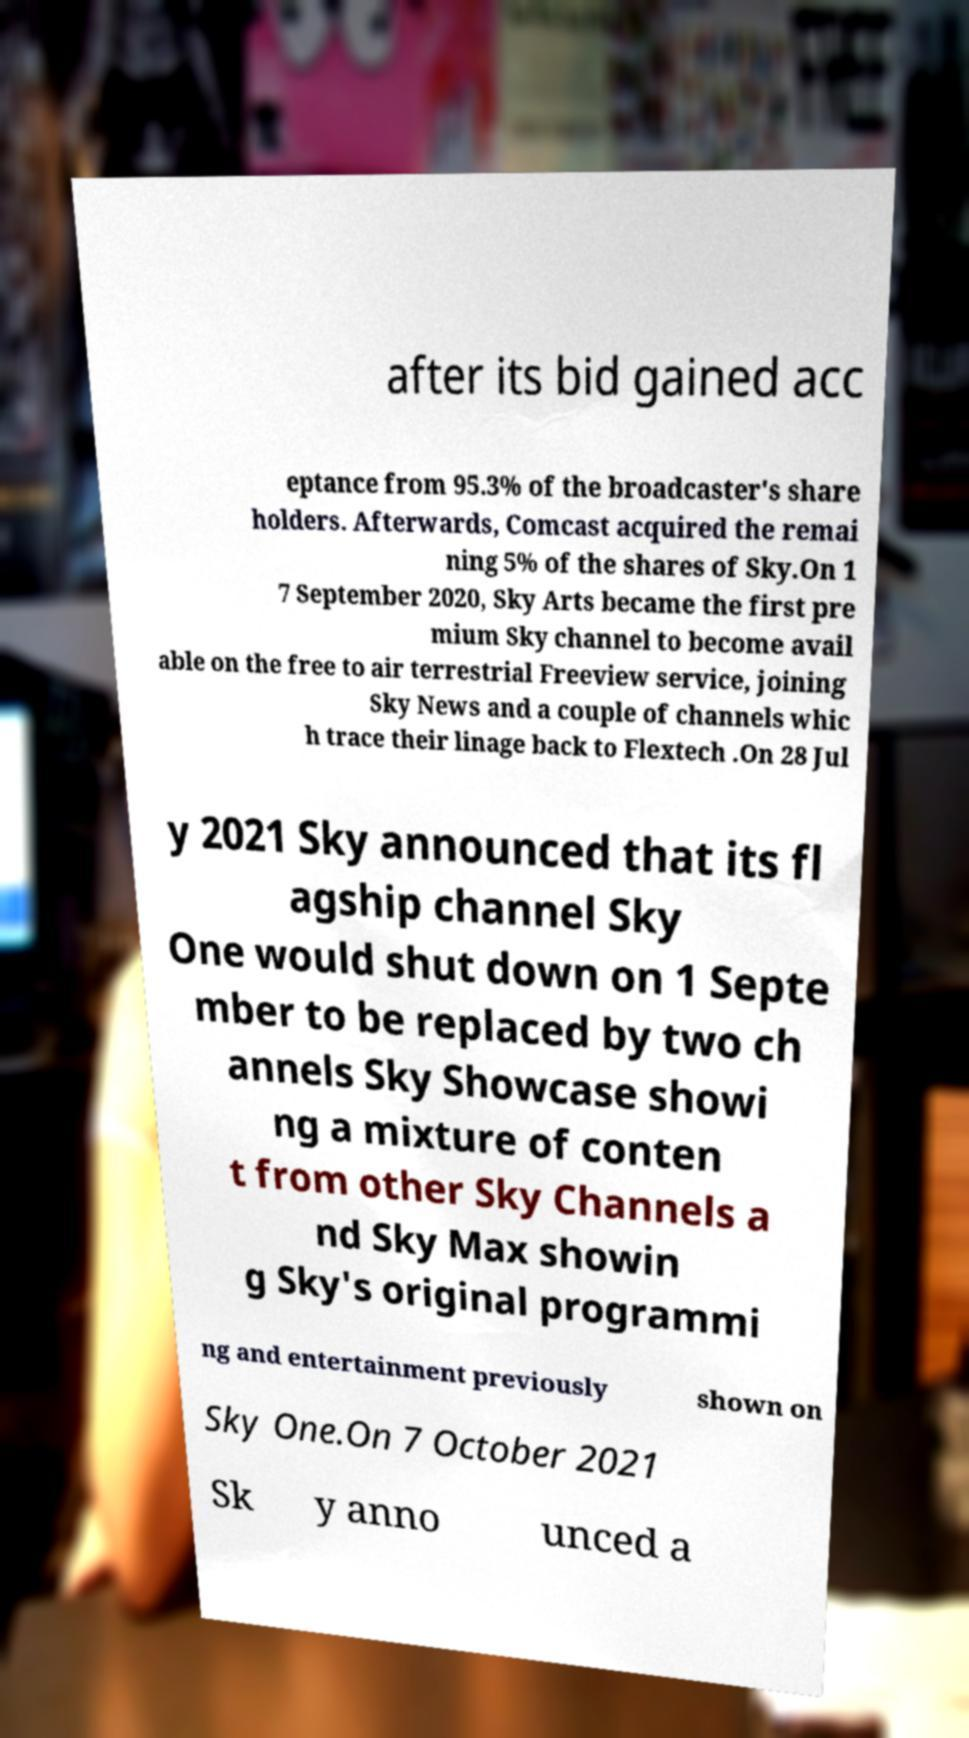Could you assist in decoding the text presented in this image and type it out clearly? after its bid gained acc eptance from 95.3% of the broadcaster's share holders. Afterwards, Comcast acquired the remai ning 5% of the shares of Sky.On 1 7 September 2020, Sky Arts became the first pre mium Sky channel to become avail able on the free to air terrestrial Freeview service, joining Sky News and a couple of channels whic h trace their linage back to Flextech .On 28 Jul y 2021 Sky announced that its fl agship channel Sky One would shut down on 1 Septe mber to be replaced by two ch annels Sky Showcase showi ng a mixture of conten t from other Sky Channels a nd Sky Max showin g Sky's original programmi ng and entertainment previously shown on Sky One.On 7 October 2021 Sk y anno unced a 